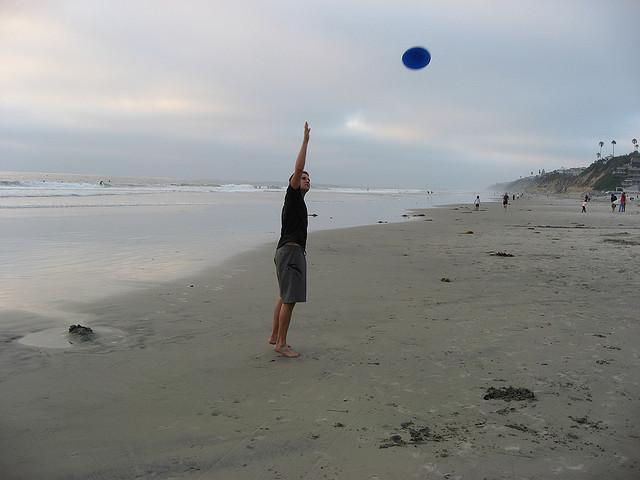How many elephant are facing the right side of the image?
Give a very brief answer. 0. 